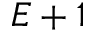<formula> <loc_0><loc_0><loc_500><loc_500>E + 1</formula> 